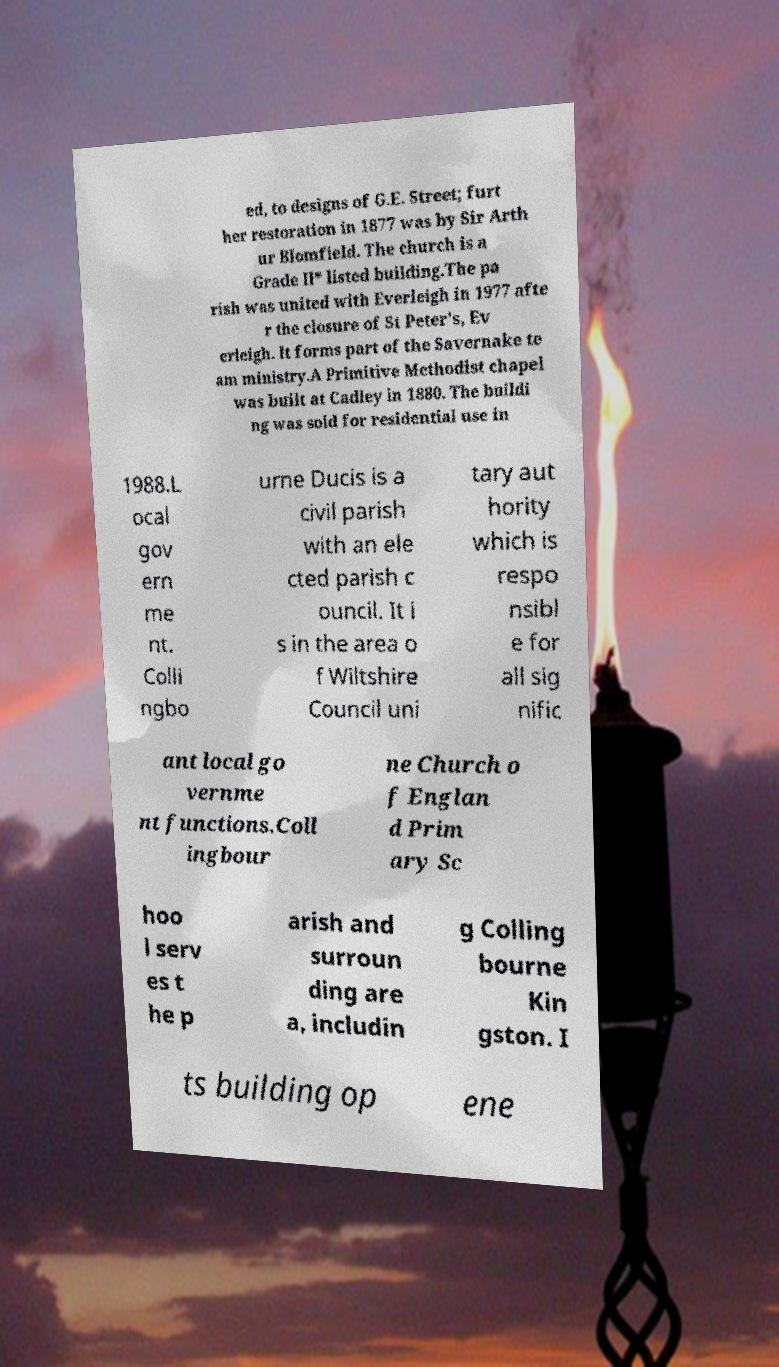There's text embedded in this image that I need extracted. Can you transcribe it verbatim? ed, to designs of G.E. Street; furt her restoration in 1877 was by Sir Arth ur Blomfield. The church is a Grade II* listed building.The pa rish was united with Everleigh in 1977 afte r the closure of St Peter's, Ev erleigh. It forms part of the Savernake te am ministry.A Primitive Methodist chapel was built at Cadley in 1880. The buildi ng was sold for residential use in 1988.L ocal gov ern me nt. Colli ngbo urne Ducis is a civil parish with an ele cted parish c ouncil. It i s in the area o f Wiltshire Council uni tary aut hority which is respo nsibl e for all sig nific ant local go vernme nt functions.Coll ingbour ne Church o f Englan d Prim ary Sc hoo l serv es t he p arish and surroun ding are a, includin g Colling bourne Kin gston. I ts building op ene 